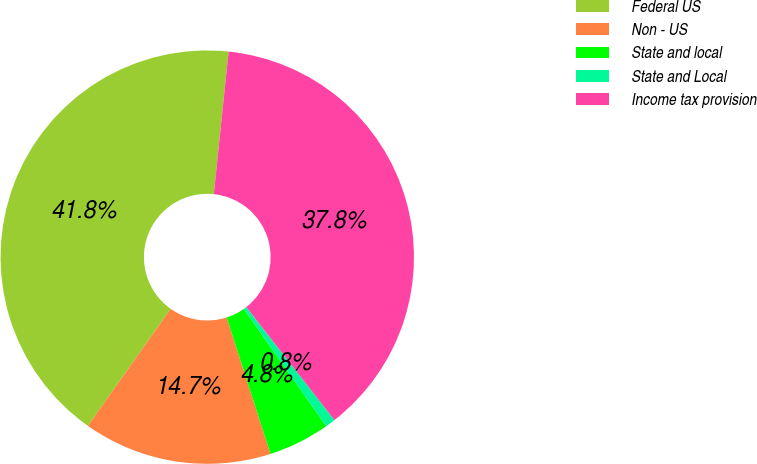Convert chart. <chart><loc_0><loc_0><loc_500><loc_500><pie_chart><fcel>Federal US<fcel>Non - US<fcel>State and local<fcel>State and Local<fcel>Income tax provision<nl><fcel>41.84%<fcel>14.75%<fcel>4.82%<fcel>0.78%<fcel>37.81%<nl></chart> 